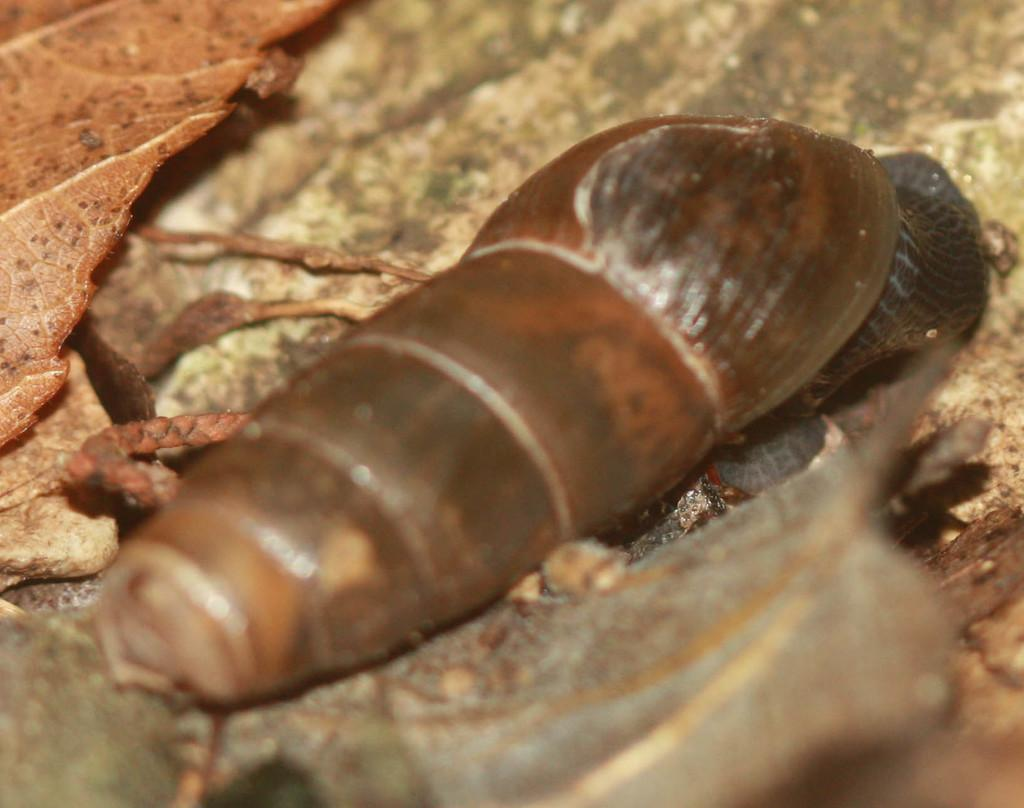What type of animal is in the image? There is a snail in the image. What else can be seen in the image besides the snail? There are leaves in the image. What type of tooth can be seen in the image? There are no teeth present in the image; it features a snail and leaves. What type of rat is visible in the image? There are no rats present in the image; it features a snail and leaves. 